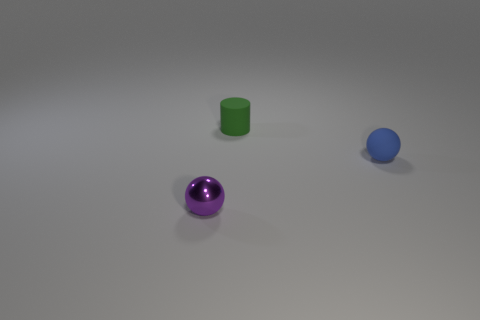Add 1 green rubber objects. How many objects exist? 4 Subtract all spheres. How many objects are left? 1 Subtract 1 purple spheres. How many objects are left? 2 Subtract all tiny rubber objects. Subtract all gray spheres. How many objects are left? 1 Add 2 balls. How many balls are left? 4 Add 1 purple blocks. How many purple blocks exist? 1 